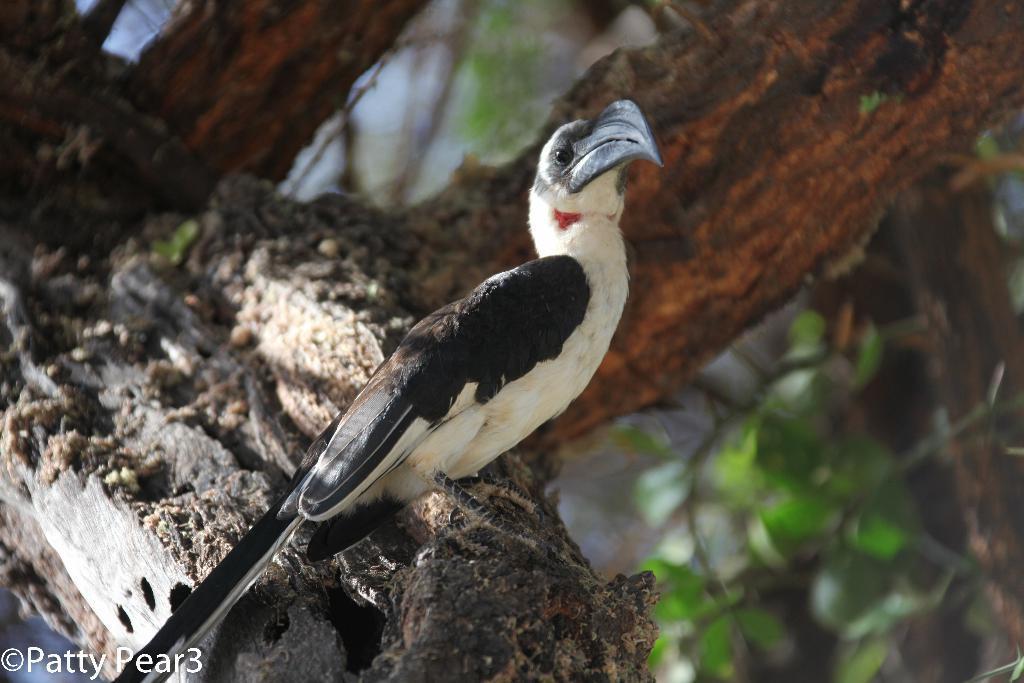Describe this image in one or two sentences. As we can see in the image, there is a bird with white and black color and behind the bird there is a tree stem. 